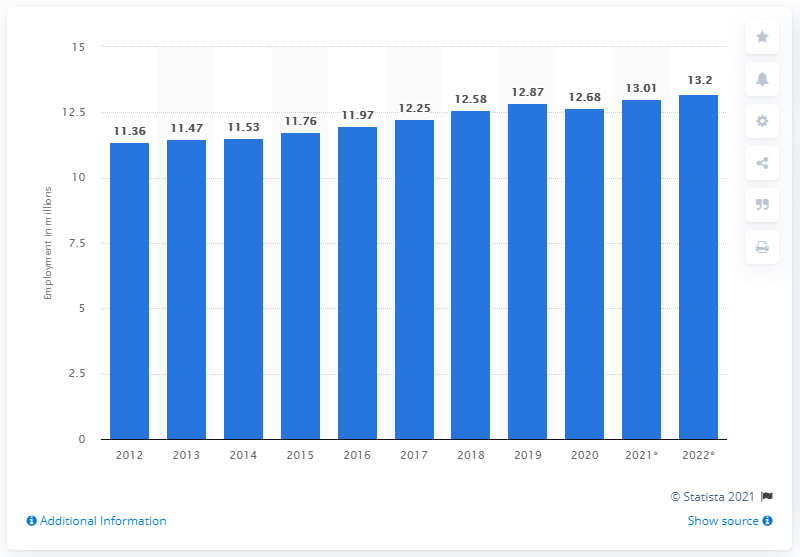Identify some key points in this picture. The employment in Australia ended in 2020. The employment in Australia ended in 2020. In 2020, there were approximately 12.68 million people employed in Australia. 